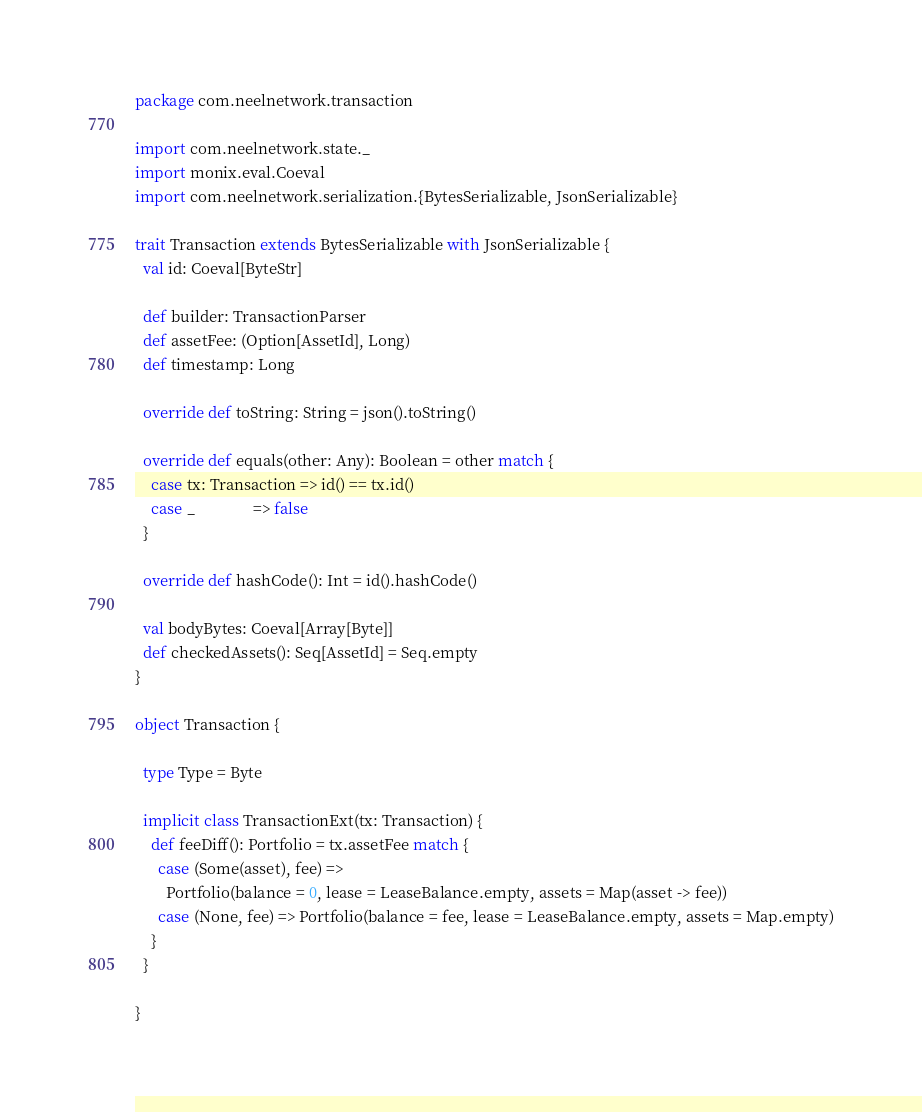Convert code to text. <code><loc_0><loc_0><loc_500><loc_500><_Scala_>package com.neelnetwork.transaction

import com.neelnetwork.state._
import monix.eval.Coeval
import com.neelnetwork.serialization.{BytesSerializable, JsonSerializable}

trait Transaction extends BytesSerializable with JsonSerializable {
  val id: Coeval[ByteStr]

  def builder: TransactionParser
  def assetFee: (Option[AssetId], Long)
  def timestamp: Long

  override def toString: String = json().toString()

  override def equals(other: Any): Boolean = other match {
    case tx: Transaction => id() == tx.id()
    case _               => false
  }

  override def hashCode(): Int = id().hashCode()

  val bodyBytes: Coeval[Array[Byte]]
  def checkedAssets(): Seq[AssetId] = Seq.empty
}

object Transaction {

  type Type = Byte

  implicit class TransactionExt(tx: Transaction) {
    def feeDiff(): Portfolio = tx.assetFee match {
      case (Some(asset), fee) =>
        Portfolio(balance = 0, lease = LeaseBalance.empty, assets = Map(asset -> fee))
      case (None, fee) => Portfolio(balance = fee, lease = LeaseBalance.empty, assets = Map.empty)
    }
  }

}
</code> 